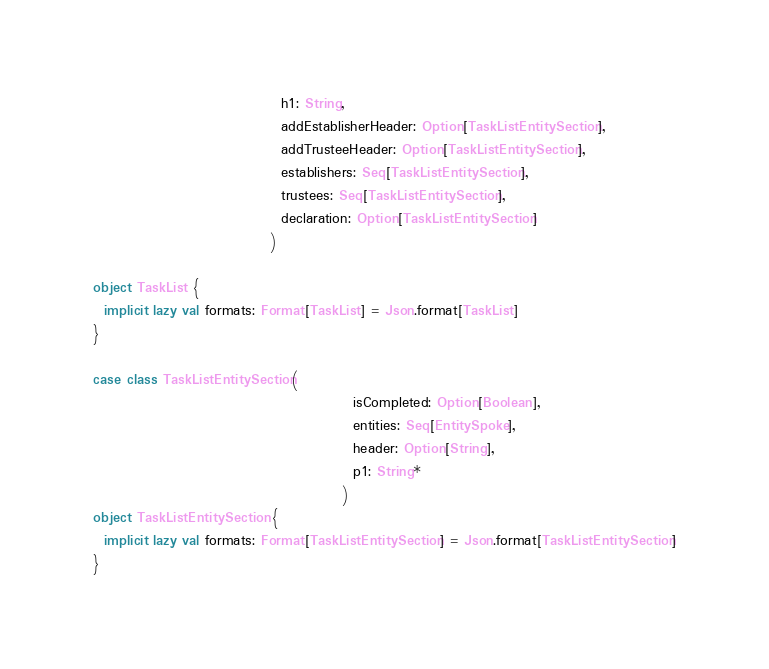<code> <loc_0><loc_0><loc_500><loc_500><_Scala_>                                  h1: String,
                                  addEstablisherHeader: Option[TaskListEntitySection],
                                  addTrusteeHeader: Option[TaskListEntitySection],
                                  establishers: Seq[TaskListEntitySection],
                                  trustees: Seq[TaskListEntitySection],
                                  declaration: Option[TaskListEntitySection]
                                )

object TaskList {
  implicit lazy val formats: Format[TaskList] = Json.format[TaskList]
}

case class TaskListEntitySection(
                                               isCompleted: Option[Boolean],
                                               entities: Seq[EntitySpoke],
                                               header: Option[String],
                                               p1: String*
                                             )
object TaskListEntitySection {
  implicit lazy val formats: Format[TaskListEntitySection] = Json.format[TaskListEntitySection]
}


</code> 